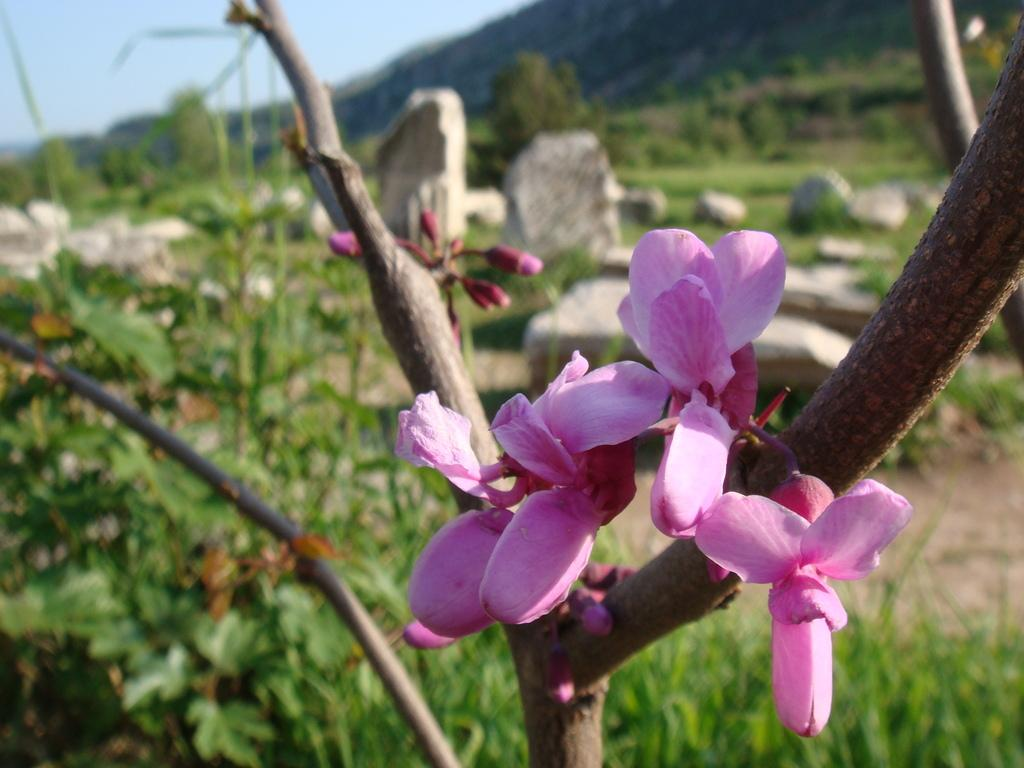What type of flowers can be seen in the image? There are pink flowers in the image. What stage of growth are some of the flowers in? There are buds in the image. What other types of plants are present in the image? There are plants in the image. What other objects can be seen in the image? There are rocks in the image. What is visible in the background of the image? The sky is visible in the image. Where can the honey be found in the image? There is no honey present in the image. What type of fish can be seen swimming in the image? There are no fish present in the image. 